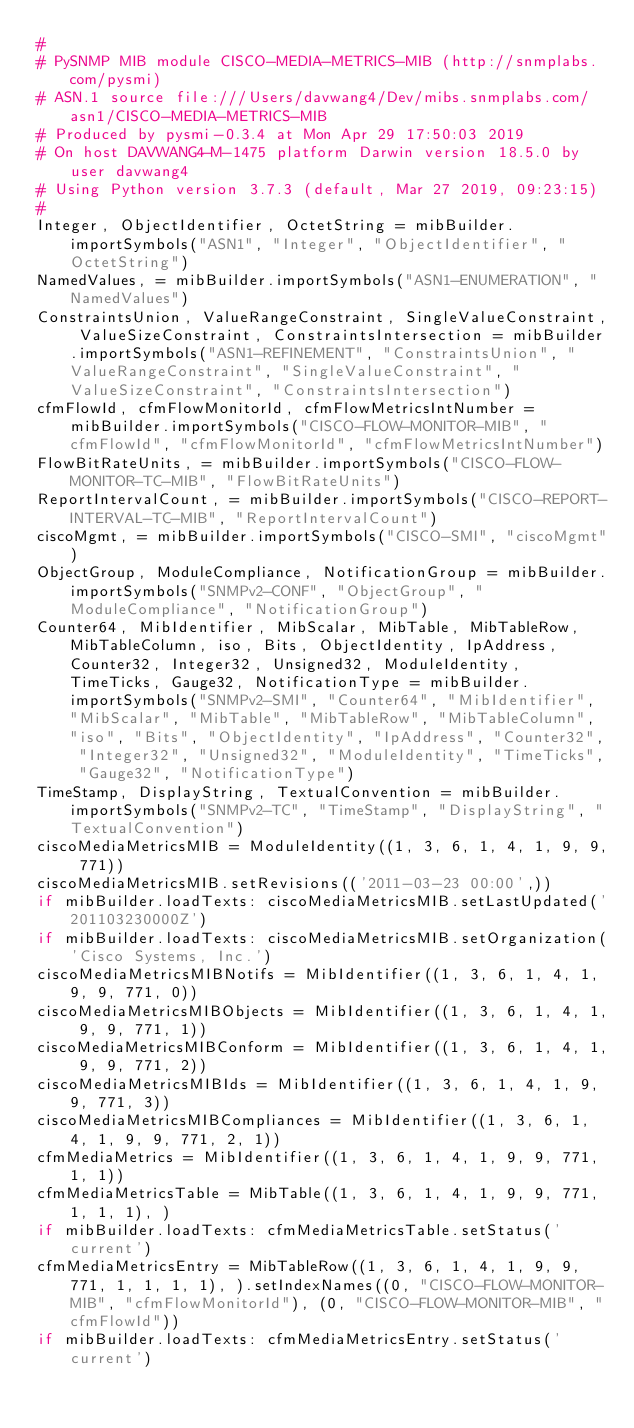<code> <loc_0><loc_0><loc_500><loc_500><_Python_>#
# PySNMP MIB module CISCO-MEDIA-METRICS-MIB (http://snmplabs.com/pysmi)
# ASN.1 source file:///Users/davwang4/Dev/mibs.snmplabs.com/asn1/CISCO-MEDIA-METRICS-MIB
# Produced by pysmi-0.3.4 at Mon Apr 29 17:50:03 2019
# On host DAVWANG4-M-1475 platform Darwin version 18.5.0 by user davwang4
# Using Python version 3.7.3 (default, Mar 27 2019, 09:23:15) 
#
Integer, ObjectIdentifier, OctetString = mibBuilder.importSymbols("ASN1", "Integer", "ObjectIdentifier", "OctetString")
NamedValues, = mibBuilder.importSymbols("ASN1-ENUMERATION", "NamedValues")
ConstraintsUnion, ValueRangeConstraint, SingleValueConstraint, ValueSizeConstraint, ConstraintsIntersection = mibBuilder.importSymbols("ASN1-REFINEMENT", "ConstraintsUnion", "ValueRangeConstraint", "SingleValueConstraint", "ValueSizeConstraint", "ConstraintsIntersection")
cfmFlowId, cfmFlowMonitorId, cfmFlowMetricsIntNumber = mibBuilder.importSymbols("CISCO-FLOW-MONITOR-MIB", "cfmFlowId", "cfmFlowMonitorId", "cfmFlowMetricsIntNumber")
FlowBitRateUnits, = mibBuilder.importSymbols("CISCO-FLOW-MONITOR-TC-MIB", "FlowBitRateUnits")
ReportIntervalCount, = mibBuilder.importSymbols("CISCO-REPORT-INTERVAL-TC-MIB", "ReportIntervalCount")
ciscoMgmt, = mibBuilder.importSymbols("CISCO-SMI", "ciscoMgmt")
ObjectGroup, ModuleCompliance, NotificationGroup = mibBuilder.importSymbols("SNMPv2-CONF", "ObjectGroup", "ModuleCompliance", "NotificationGroup")
Counter64, MibIdentifier, MibScalar, MibTable, MibTableRow, MibTableColumn, iso, Bits, ObjectIdentity, IpAddress, Counter32, Integer32, Unsigned32, ModuleIdentity, TimeTicks, Gauge32, NotificationType = mibBuilder.importSymbols("SNMPv2-SMI", "Counter64", "MibIdentifier", "MibScalar", "MibTable", "MibTableRow", "MibTableColumn", "iso", "Bits", "ObjectIdentity", "IpAddress", "Counter32", "Integer32", "Unsigned32", "ModuleIdentity", "TimeTicks", "Gauge32", "NotificationType")
TimeStamp, DisplayString, TextualConvention = mibBuilder.importSymbols("SNMPv2-TC", "TimeStamp", "DisplayString", "TextualConvention")
ciscoMediaMetricsMIB = ModuleIdentity((1, 3, 6, 1, 4, 1, 9, 9, 771))
ciscoMediaMetricsMIB.setRevisions(('2011-03-23 00:00',))
if mibBuilder.loadTexts: ciscoMediaMetricsMIB.setLastUpdated('201103230000Z')
if mibBuilder.loadTexts: ciscoMediaMetricsMIB.setOrganization('Cisco Systems, Inc.')
ciscoMediaMetricsMIBNotifs = MibIdentifier((1, 3, 6, 1, 4, 1, 9, 9, 771, 0))
ciscoMediaMetricsMIBObjects = MibIdentifier((1, 3, 6, 1, 4, 1, 9, 9, 771, 1))
ciscoMediaMetricsMIBConform = MibIdentifier((1, 3, 6, 1, 4, 1, 9, 9, 771, 2))
ciscoMediaMetricsMIBIds = MibIdentifier((1, 3, 6, 1, 4, 1, 9, 9, 771, 3))
ciscoMediaMetricsMIBCompliances = MibIdentifier((1, 3, 6, 1, 4, 1, 9, 9, 771, 2, 1))
cfmMediaMetrics = MibIdentifier((1, 3, 6, 1, 4, 1, 9, 9, 771, 1, 1))
cfmMediaMetricsTable = MibTable((1, 3, 6, 1, 4, 1, 9, 9, 771, 1, 1, 1), )
if mibBuilder.loadTexts: cfmMediaMetricsTable.setStatus('current')
cfmMediaMetricsEntry = MibTableRow((1, 3, 6, 1, 4, 1, 9, 9, 771, 1, 1, 1, 1), ).setIndexNames((0, "CISCO-FLOW-MONITOR-MIB", "cfmFlowMonitorId"), (0, "CISCO-FLOW-MONITOR-MIB", "cfmFlowId"))
if mibBuilder.loadTexts: cfmMediaMetricsEntry.setStatus('current')</code> 